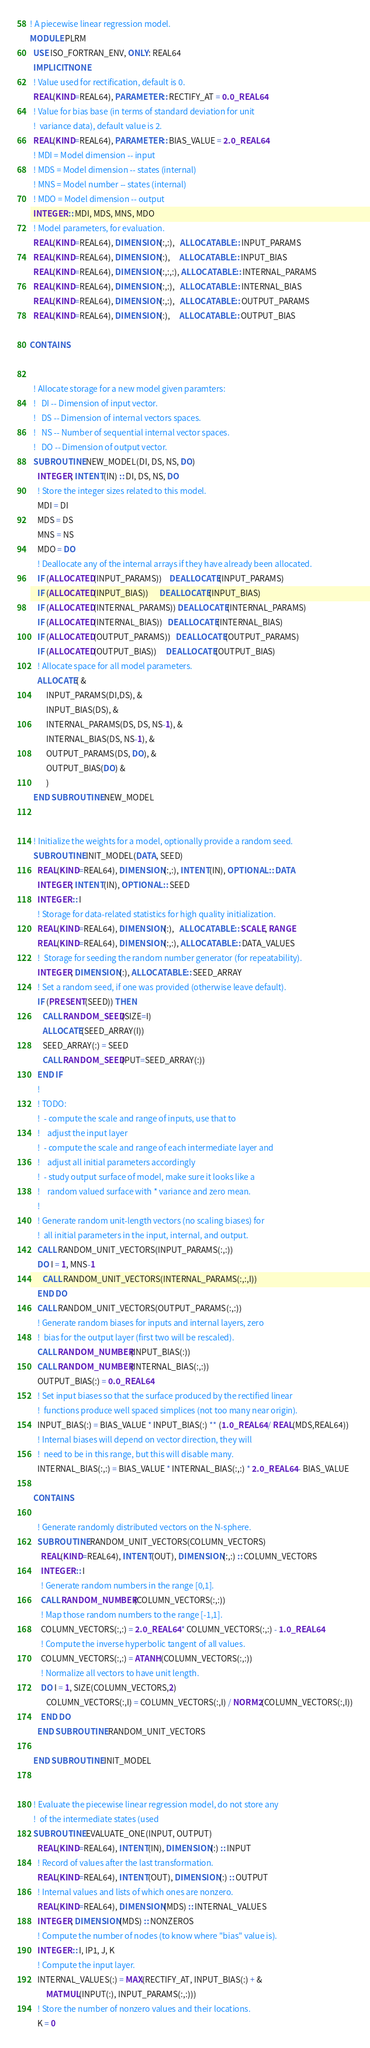Convert code to text. <code><loc_0><loc_0><loc_500><loc_500><_FORTRAN_>! A piecewise linear regression model.
MODULE PLRM
  USE ISO_FORTRAN_ENV, ONLY: REAL64
  IMPLICIT NONE
  ! Value used for rectification, default is 0.
  REAL(KIND=REAL64), PARAMETER :: RECTIFY_AT = 0.0_REAL64
  ! Value for bias base (in terms of standard deviation for unit
  !  variance data), default value is 2.
  REAL(KIND=REAL64), PARAMETER :: BIAS_VALUE = 2.0_REAL64
  ! MDI = Model dimension -- input
  ! MDS = Model dimension -- states (internal)
  ! MNS = Model number -- states (internal)
  ! MDO = Model dimension -- output
  INTEGER :: MDI, MDS, MNS, MDO
  ! Model parameters, for evaluation.
  REAL(KIND=REAL64), DIMENSION(:,:),   ALLOCATABLE :: INPUT_PARAMS
  REAL(KIND=REAL64), DIMENSION(:),     ALLOCATABLE :: INPUT_BIAS
  REAL(KIND=REAL64), DIMENSION(:,:,:), ALLOCATABLE :: INTERNAL_PARAMS
  REAL(KIND=REAL64), DIMENSION(:,:),   ALLOCATABLE :: INTERNAL_BIAS
  REAL(KIND=REAL64), DIMENSION(:,:),   ALLOCATABLE :: OUTPUT_PARAMS
  REAL(KIND=REAL64), DIMENSION(:),     ALLOCATABLE :: OUTPUT_BIAS
  
CONTAINS


  ! Allocate storage for a new model given paramters:
  !   DI -- Dimension of input vector.
  !   DS -- Dimension of internal vectors spaces.
  !   NS -- Number of sequential internal vector spaces.
  !   DO -- Dimension of output vector.
  SUBROUTINE NEW_MODEL(DI, DS, NS, DO)
    INTEGER, INTENT(IN) :: DI, DS, NS, DO
    ! Store the integer sizes related to this model.
    MDI = DI
    MDS = DS
    MNS = NS
    MDO = DO
    ! Deallocate any of the internal arrays if they have already been allocated.
    IF (ALLOCATED(INPUT_PARAMS))    DEALLOCATE(INPUT_PARAMS)
    IF (ALLOCATED(INPUT_BIAS))      DEALLOCATE(INPUT_BIAS)
    IF (ALLOCATED(INTERNAL_PARAMS)) DEALLOCATE(INTERNAL_PARAMS)
    IF (ALLOCATED(INTERNAL_BIAS))   DEALLOCATE(INTERNAL_BIAS)
    IF (ALLOCATED(OUTPUT_PARAMS))   DEALLOCATE(OUTPUT_PARAMS)
    IF (ALLOCATED(OUTPUT_BIAS))     DEALLOCATE(OUTPUT_BIAS)
    ! Allocate space for all model parameters.
    ALLOCATE( &
         INPUT_PARAMS(DI,DS), &
         INPUT_BIAS(DS), &
         INTERNAL_PARAMS(DS, DS, NS-1), &
         INTERNAL_BIAS(DS, NS-1), &
         OUTPUT_PARAMS(DS, DO), &
         OUTPUT_BIAS(DO) &
         )
  END SUBROUTINE NEW_MODEL


  ! Initialize the weights for a model, optionally provide a random seed.
  SUBROUTINE INIT_MODEL(DATA, SEED)
    REAL(KIND=REAL64), DIMENSION(:,:), INTENT(IN), OPTIONAL :: DATA
    INTEGER, INTENT(IN), OPTIONAL :: SEED
    INTEGER :: I
    ! Storage for data-related statistics for high quality initialization.
    REAL(KIND=REAL64), DIMENSION(:),   ALLOCATABLE :: SCALE, RANGE
    REAL(KIND=REAL64), DIMENSION(:,:), ALLOCATABLE :: DATA_VALUES
    !  Storage for seeding the random number generator (for repeatability).
    INTEGER, DIMENSION(:), ALLOCATABLE :: SEED_ARRAY
    ! Set a random seed, if one was provided (otherwise leave default).
    IF (PRESENT(SEED)) THEN
       CALL RANDOM_SEED(SIZE=I)
       ALLOCATE(SEED_ARRAY(I))
       SEED_ARRAY(:) = SEED
       CALL RANDOM_SEED(PUT=SEED_ARRAY(:))
    END IF
    ! 
    ! TODO:
    !  - compute the scale and range of inputs, use that to 
    !    adjust the input layer
    !  - compute the scale and range of each intermediate layer and
    !    adjust all initial parameters accordingly
    !  - study output surface of model, make sure it looks like a
    !    random valued surface with * variance and zero mean.
    ! 
    ! Generate random unit-length vectors (no scaling biases) for
    !  all initial parameters in the input, internal, and output.
    CALL RANDOM_UNIT_VECTORS(INPUT_PARAMS(:,:))
    DO I = 1, MNS-1
       CALL RANDOM_UNIT_VECTORS(INTERNAL_PARAMS(:,:,I))
    END DO
    CALL RANDOM_UNIT_VECTORS(OUTPUT_PARAMS(:,:))
    ! Generate random biases for inputs and internal layers, zero
    !  bias for the output layer (first two will be rescaled).
    CALL RANDOM_NUMBER(INPUT_BIAS(:))
    CALL RANDOM_NUMBER(INTERNAL_BIAS(:,:))
    OUTPUT_BIAS(:) = 0.0_REAL64
    ! Set input biases so that the surface produced by the rectified linear
    !  functions produce well spaced simplices (not too many near origin).
    INPUT_BIAS(:) = BIAS_VALUE * INPUT_BIAS(:) ** (1.0_REAL64 / REAL(MDS,REAL64))
    ! Internal biases will depend on vector direction, they will
    !  need to be in this range, but this will disable many.
    INTERNAL_BIAS(:,:) = BIAS_VALUE * INTERNAL_BIAS(:,:) * 2.0_REAL64 - BIAS_VALUE

  CONTAINS

    ! Generate randomly distributed vectors on the N-sphere.
    SUBROUTINE RANDOM_UNIT_VECTORS(COLUMN_VECTORS)
      REAL(KIND=REAL64), INTENT(OUT), DIMENSION(:,:) :: COLUMN_VECTORS
      INTEGER :: I 
      ! Generate random numbers in the range [0,1].
      CALL RANDOM_NUMBER(COLUMN_VECTORS(:,:))
      ! Map those random numbers to the range [-1,1].
      COLUMN_VECTORS(:,:) = 2.0_REAL64 * COLUMN_VECTORS(:,:) - 1.0_REAL64
      ! Compute the inverse hyperbolic tangent of all values.
      COLUMN_VECTORS(:,:) = ATANH(COLUMN_VECTORS(:,:))
      ! Normalize all vectors to have unit length.
      DO I = 1, SIZE(COLUMN_VECTORS,2)
         COLUMN_VECTORS(:,I) = COLUMN_VECTORS(:,I) / NORM2(COLUMN_VECTORS(:,I))
      END DO
    END SUBROUTINE RANDOM_UNIT_VECTORS

  END SUBROUTINE INIT_MODEL


  ! Evaluate the piecewise linear regression model, do not store any
  !  of the intermediate states (used 
  SUBROUTINE EVALUATE_ONE(INPUT, OUTPUT)
    REAL(KIND=REAL64), INTENT(IN), DIMENSION(:) :: INPUT
    ! Record of values after the last transformation.
    REAL(KIND=REAL64), INTENT(OUT), DIMENSION(:) :: OUTPUT
    ! Internal values and lists of which ones are nonzero.
    REAL(KIND=REAL64), DIMENSION(MDS) :: INTERNAL_VALUES
    INTEGER, DIMENSION(MDS) :: NONZEROS
    ! Compute the number of nodes (to know where "bias" value is).
    INTEGER :: I, IP1, J, K
    ! Compute the input layer.
    INTERNAL_VALUES(:) = MAX(RECTIFY_AT, INPUT_BIAS(:) + &
         MATMUL(INPUT(:), INPUT_PARAMS(:,:)))
    ! Store the number of nonzero values and their locations.
    K = 0</code> 